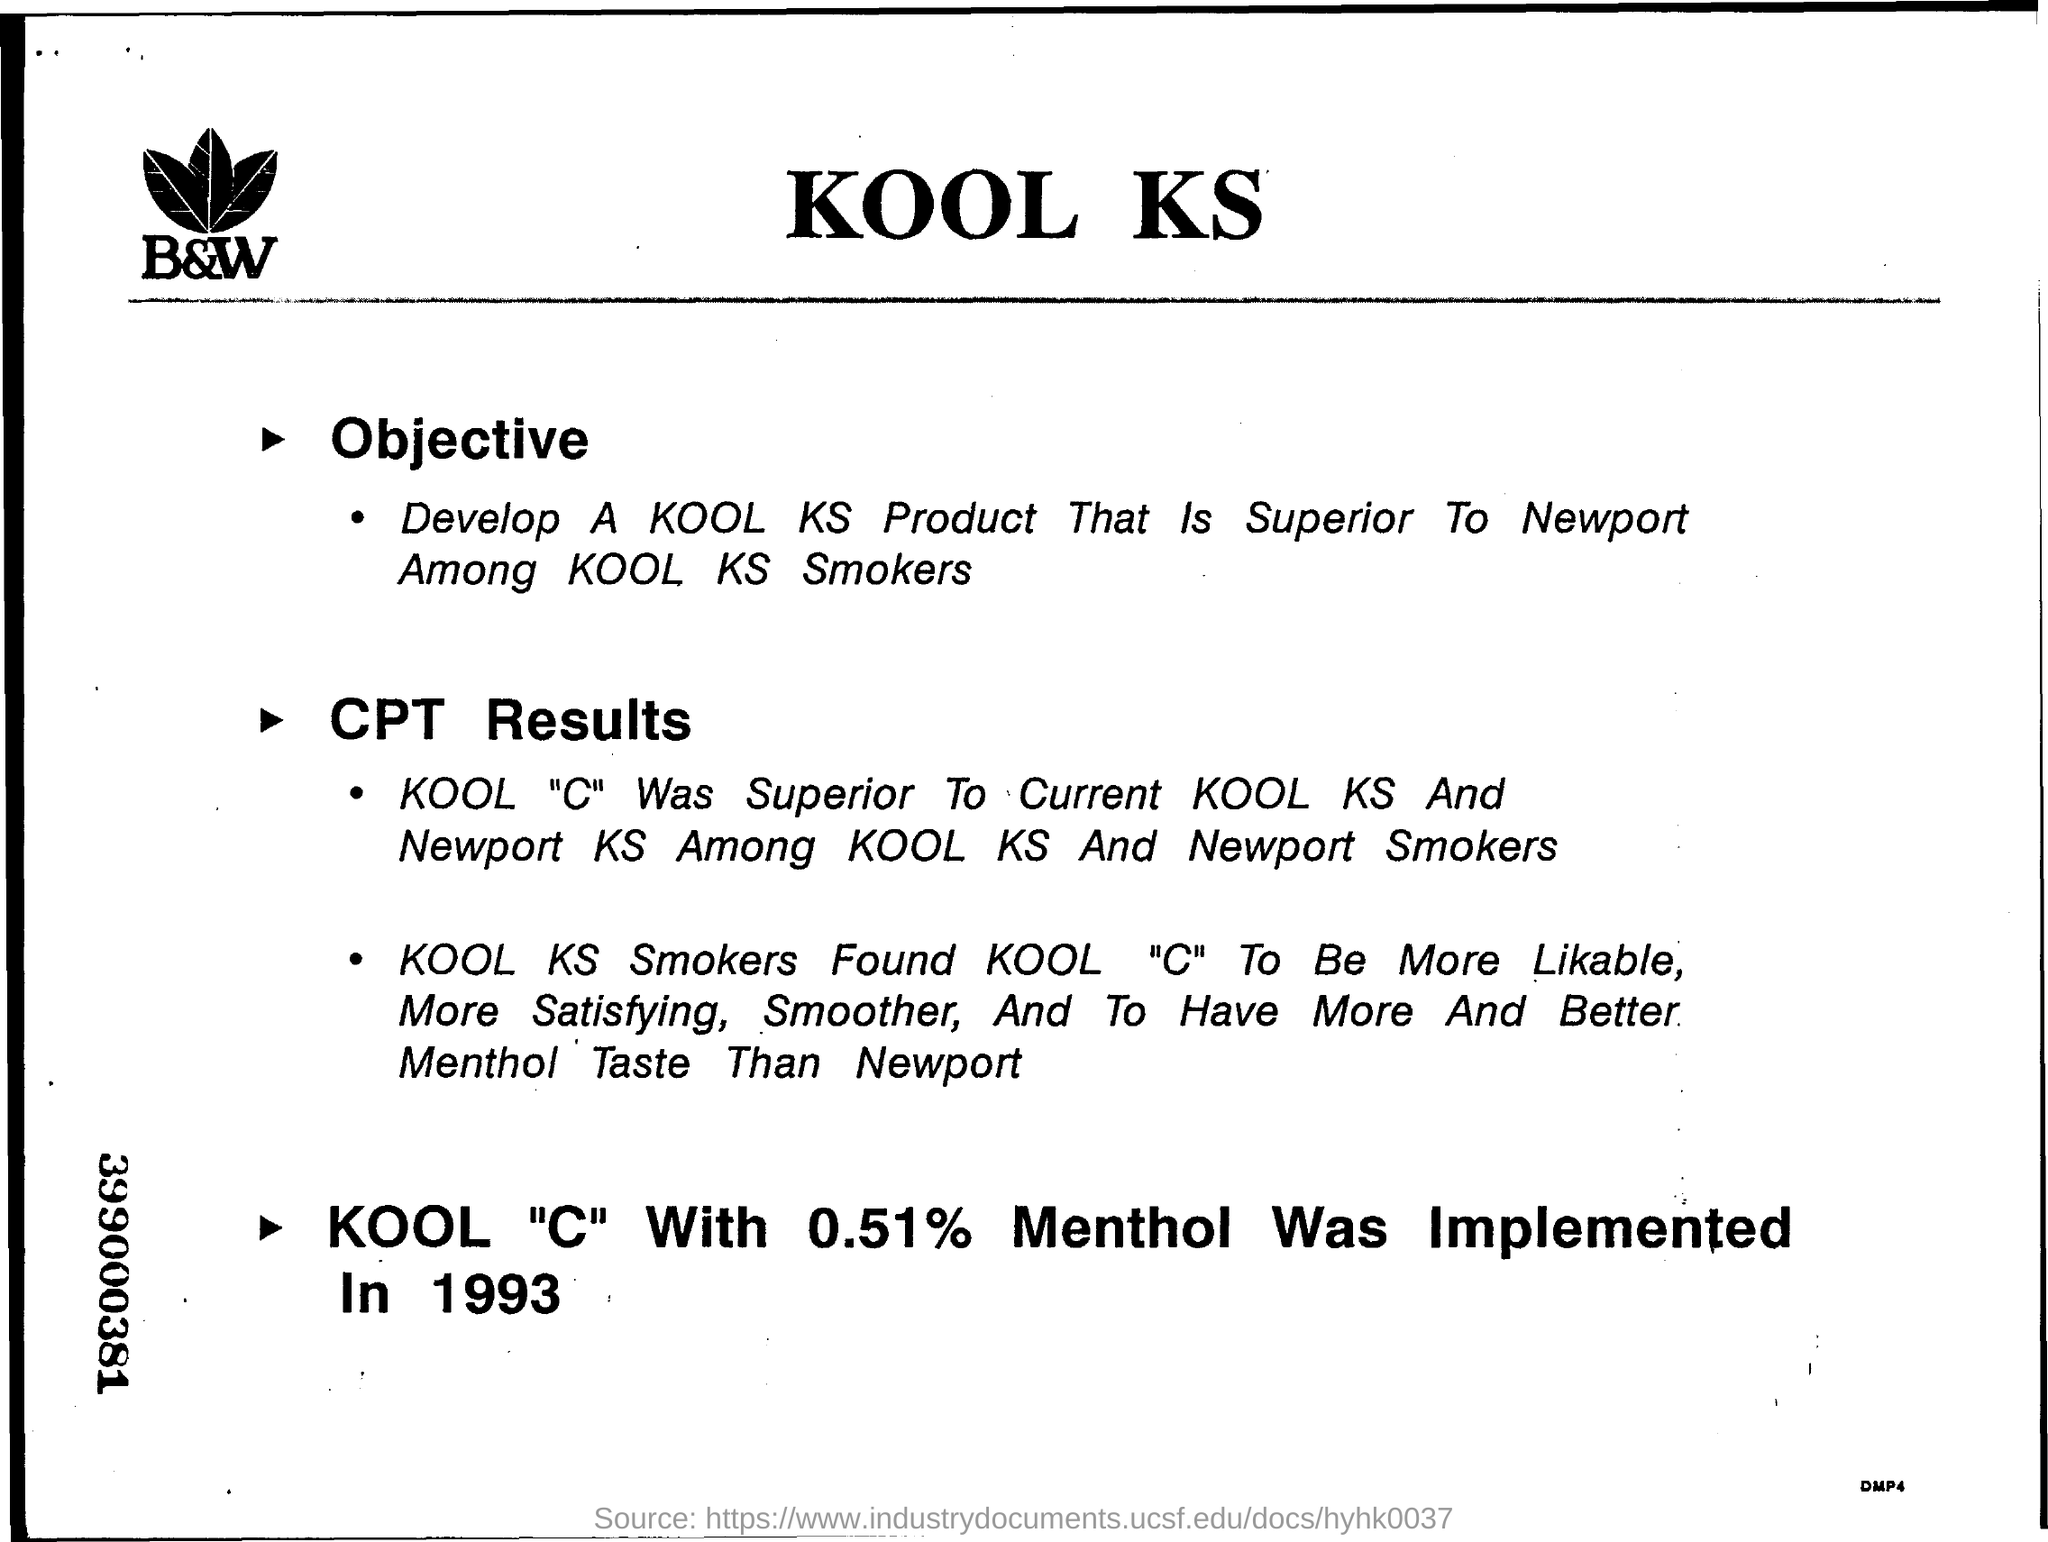Indicate a few pertinent items in this graphic. The KOOL "C" with 0.51% menthol was implemented in 1993. The objective of this document is to develop a KOOL KS product that is superior to Newport among KOOL KS smokers. The heading of the document is 'Kool KS'. The number on the left margin is 399000381, consisting of nine digits. 